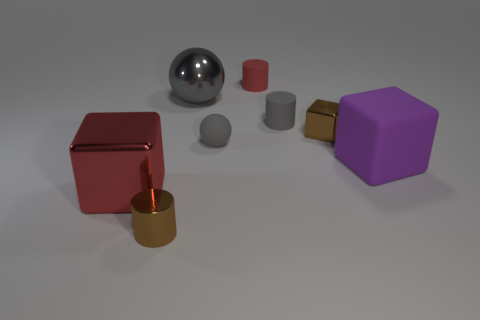Is the number of big purple matte blocks less than the number of green rubber blocks?
Offer a terse response. No. How big is the gray matte object that is on the right side of the small red thing?
Offer a terse response. Small. The thing that is both left of the tiny ball and behind the small gray rubber ball has what shape?
Provide a short and direct response. Sphere. There is a gray matte thing that is the same shape as the gray shiny thing; what is its size?
Provide a short and direct response. Small. What number of small gray spheres have the same material as the purple object?
Provide a succinct answer. 1. Is the color of the big rubber object the same as the large metal thing that is behind the small sphere?
Provide a succinct answer. No. Is the number of gray cylinders greater than the number of brown things?
Your answer should be very brief. No. The matte ball has what color?
Offer a very short reply. Gray. There is a small thing that is left of the gray rubber ball; does it have the same color as the big metallic cube?
Provide a short and direct response. No. What is the material of the thing that is the same color as the metallic cylinder?
Your response must be concise. Metal. 